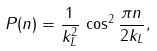<formula> <loc_0><loc_0><loc_500><loc_500>P ( n ) = { \frac { 1 } { k ^ { 2 } _ { L } } } \, \cos ^ { 2 } { \frac { \pi n } { 2 k _ { L } } } ,</formula> 